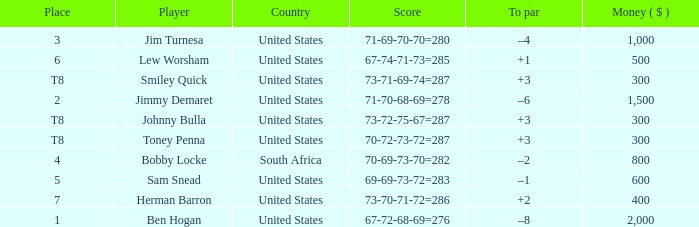What is the To par of the Player with a Score of 73-70-71-72=286? 2.0. 